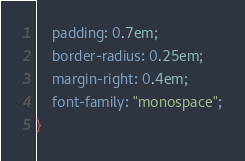<code> <loc_0><loc_0><loc_500><loc_500><_CSS_>    padding: 0.7em;
    border-radius: 0.25em;
    margin-right: 0.4em;
    font-family: "monospace";
}</code> 